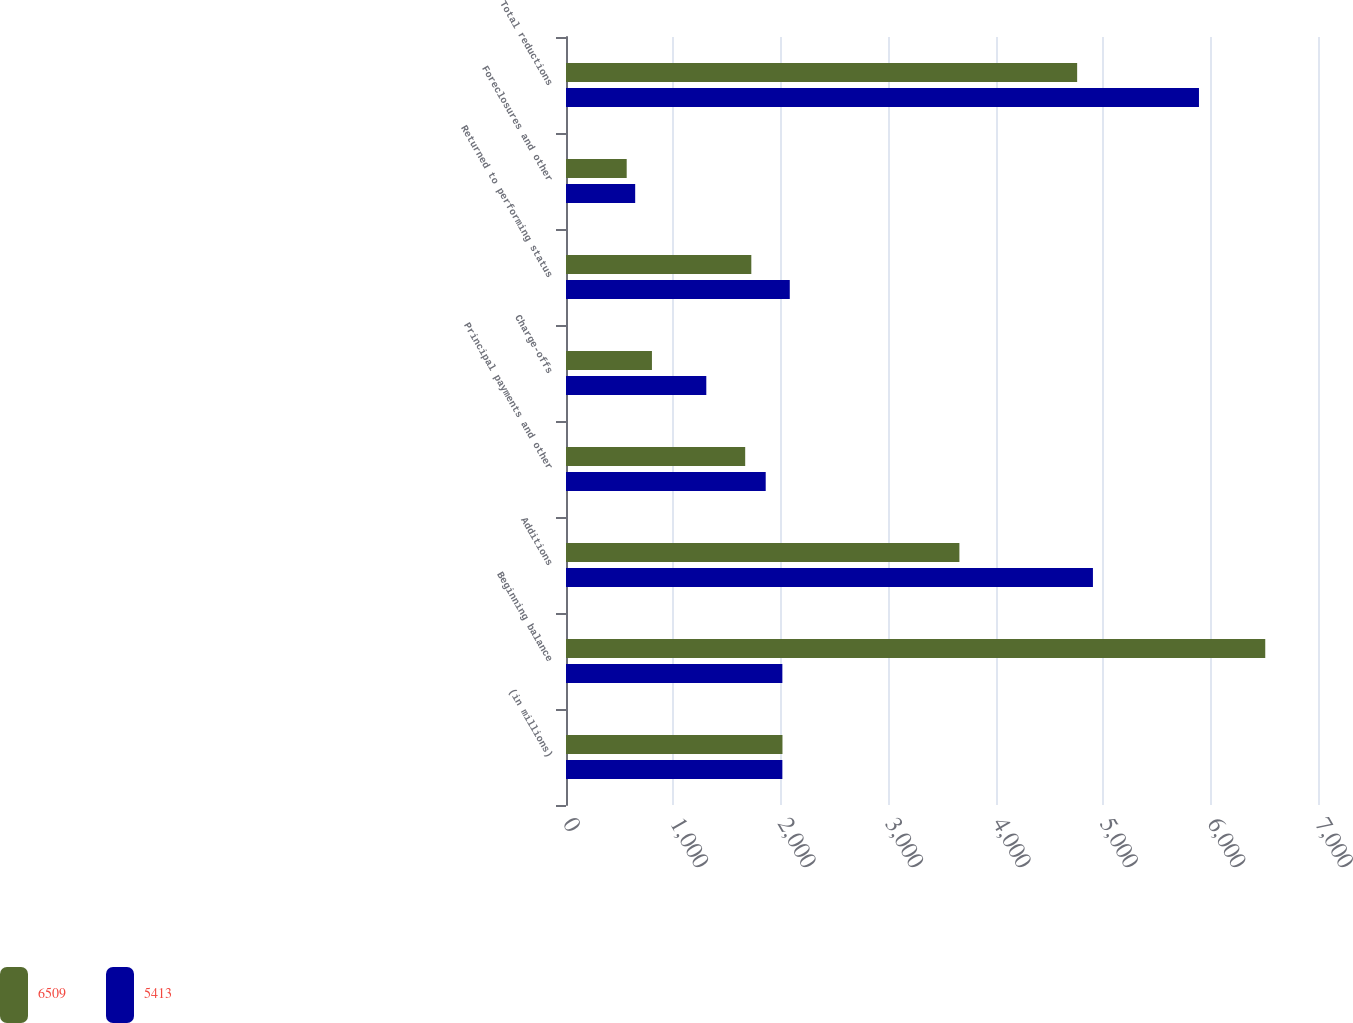<chart> <loc_0><loc_0><loc_500><loc_500><stacked_bar_chart><ecel><fcel>(in millions)<fcel>Beginning balance<fcel>Additions<fcel>Principal payments and other<fcel>Charge-offs<fcel>Returned to performing status<fcel>Foreclosures and other<fcel>Total reductions<nl><fcel>6509<fcel>2015<fcel>6509<fcel>3662<fcel>1668<fcel>800<fcel>1725<fcel>565<fcel>4758<nl><fcel>5413<fcel>2014<fcel>2014<fcel>4905<fcel>1859<fcel>1306<fcel>2083<fcel>644<fcel>5892<nl></chart> 